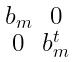Convert formula to latex. <formula><loc_0><loc_0><loc_500><loc_500>\begin{smallmatrix} b _ { m } & 0 \\ 0 & b _ { m } ^ { t } \end{smallmatrix}</formula> 